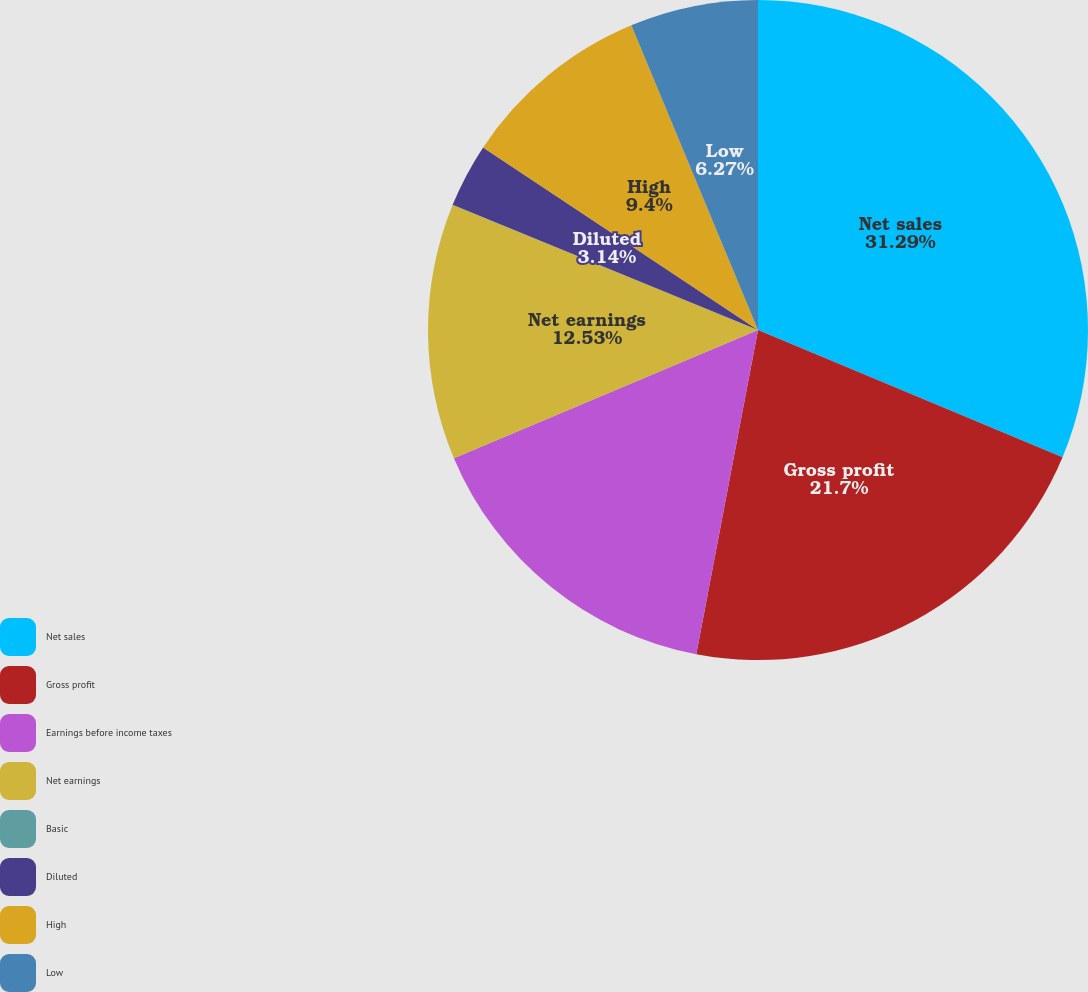<chart> <loc_0><loc_0><loc_500><loc_500><pie_chart><fcel>Net sales<fcel>Gross profit<fcel>Earnings before income taxes<fcel>Net earnings<fcel>Basic<fcel>Diluted<fcel>High<fcel>Low<nl><fcel>31.3%<fcel>21.7%<fcel>15.66%<fcel>12.53%<fcel>0.01%<fcel>3.14%<fcel>9.4%<fcel>6.27%<nl></chart> 